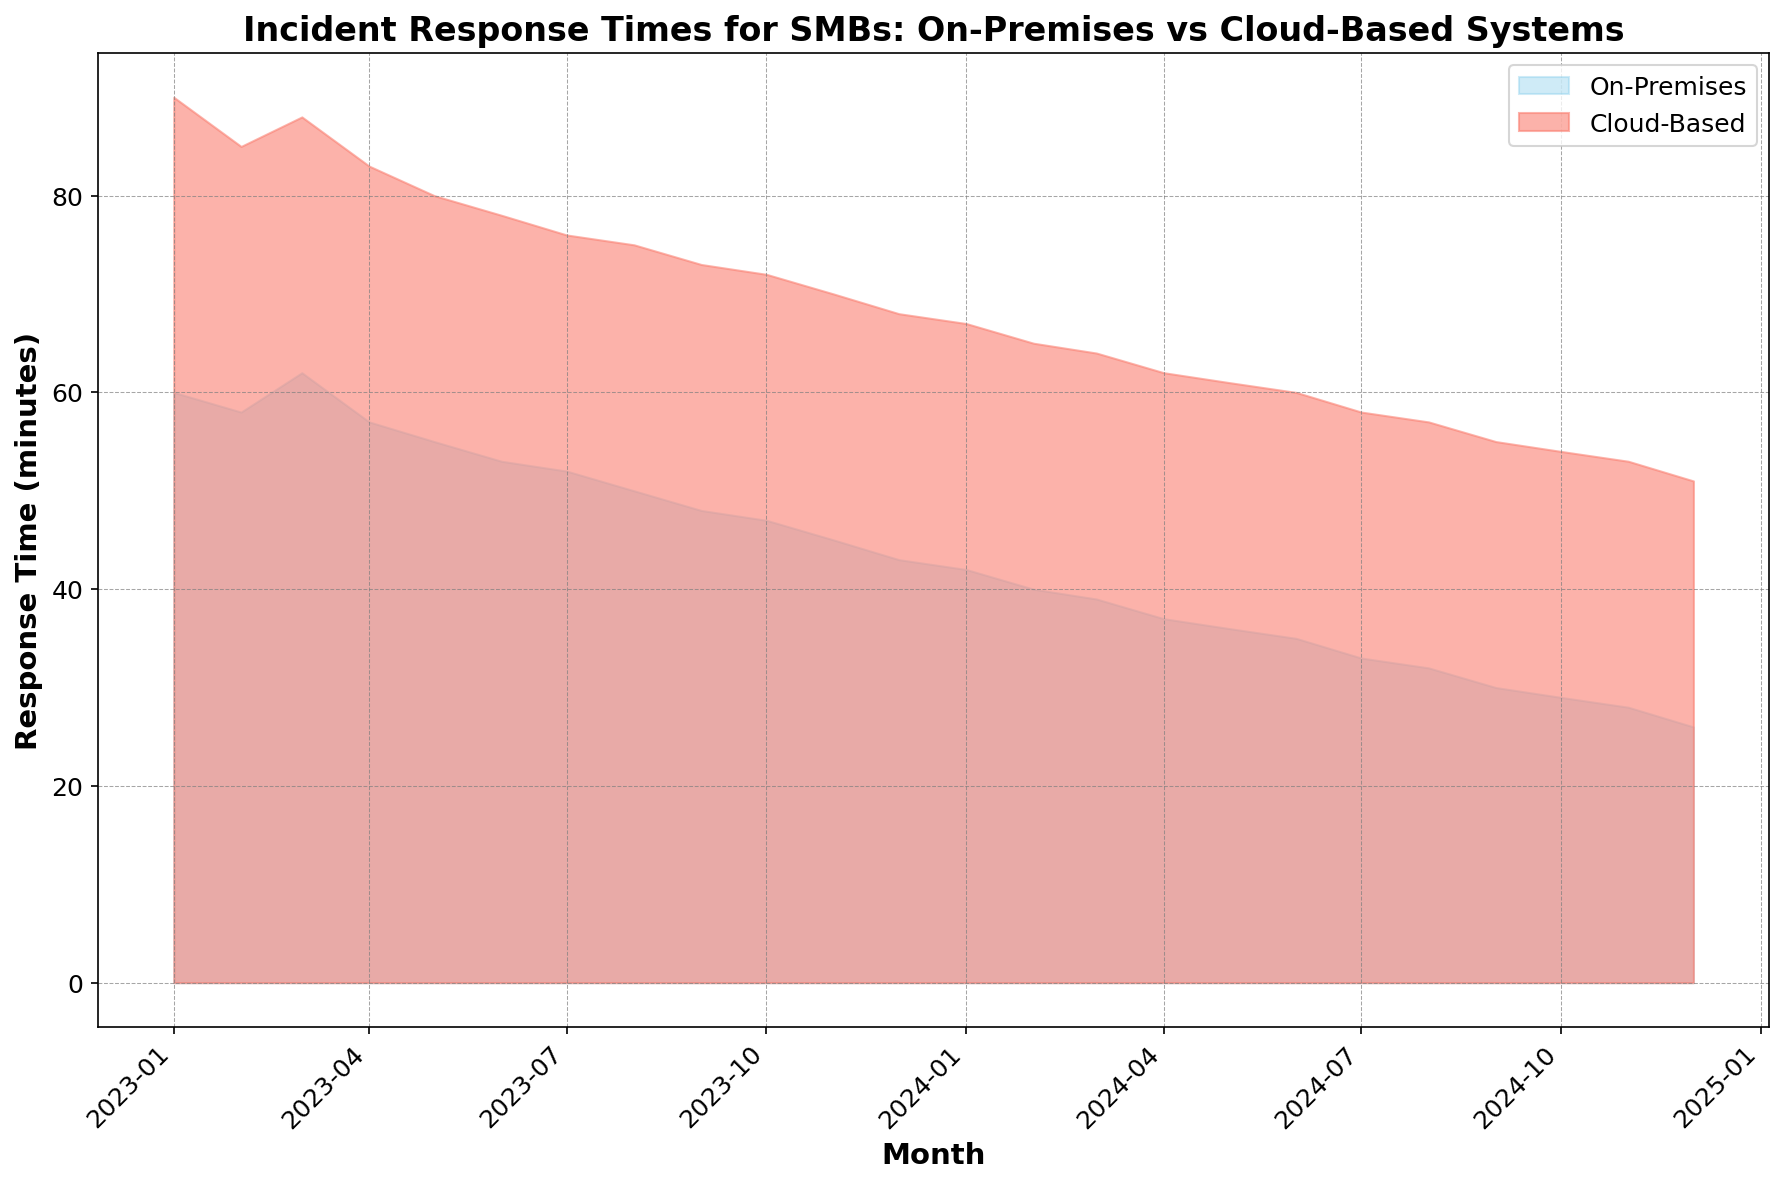What is the average response time for on-premises systems over the entire period? Sum all the on-premises response times and divide by the number of months. That is: (60 + 58 + 62 + 57 + 55 + 53 + 52 + 50 + 48 + 47 + 45 + 43 + 42 + 40 + 39 + 37 + 36 + 35 + 33 + 32 + 30 + 29 + 28 + 26) / 24 = 913 / 24 ≈ 38.04
Answer: 38.04 minutes How much did the cloud-based response time decrease from January 2023 to December 2024? Subtract the cloud-based response time in December 2024 from January 2023: 90 (Jan 2023) - 51 (Dec 2024) = 39 minutes
Answer: 39 minutes Which system had a lower response time in November 2023, and by how much? Compare the response times of both systems in November 2023: On-Premises = 45 minutes, Cloud-Based = 70 minutes. The difference is 70 - 45 = 25 minutes.
Answer: On-Premises, 25 minutes In which month was the difference between on-premises and cloud-based response times the greatest? Calculate the differences for each month and identify the maximum: differences are 2023-01 (30), 2023-02 (27), 2023-03 (26), 2023-04 (26), 2023-05 (25), 2023-06 (25), 2023-07 (24), 2023-08 (25), 2023-09 (25), 2023-10 (25), 2023-11 (25), 2023-12 (25), 2024-01 (25), 2024-02 (25), 2024-03 (24), 2024-04 (25), 2024-05 (25), 2024-06 (25), 2024-07 (25), 2024-08 (25), 2024-09 (25), 2024-10 (25), 2024-11 (25), 2024-12 (25). The greatest difference is in January 2023
Answer: January 2023 By how much did the on-premises response time decrease from June 2023 to December 2024? Subtract the on-premises response time in December 2024 from June 2023: 53 (June 2023) - 26 (Dec 2024) = 27 minutes
Answer: 27 minutes Which system consistently had a higher response time throughout the period? Examine the plotted areas of both on-premises and cloud-based systems for the entire period. The cloud-based system's area is consistently above the on-premises system's area throughout the period.
Answer: Cloud-based What is the visual difference in colors used for the on-premises and cloud-based response times in the chart? Visually identify the colors used for each system: On-Premises is represented in sky blue while Cloud-Based Response is in salmon color.
Answer: Sky blue for On-Premises, Salmon for Cloud-Based Is there any month where the response time for cloud-based systems was lower than that for on-premises systems? Visually inspect each month's response time and confirm that for all months, the response time for cloud-based systems is always higher than the response time for on-premises systems.
Answer: No 